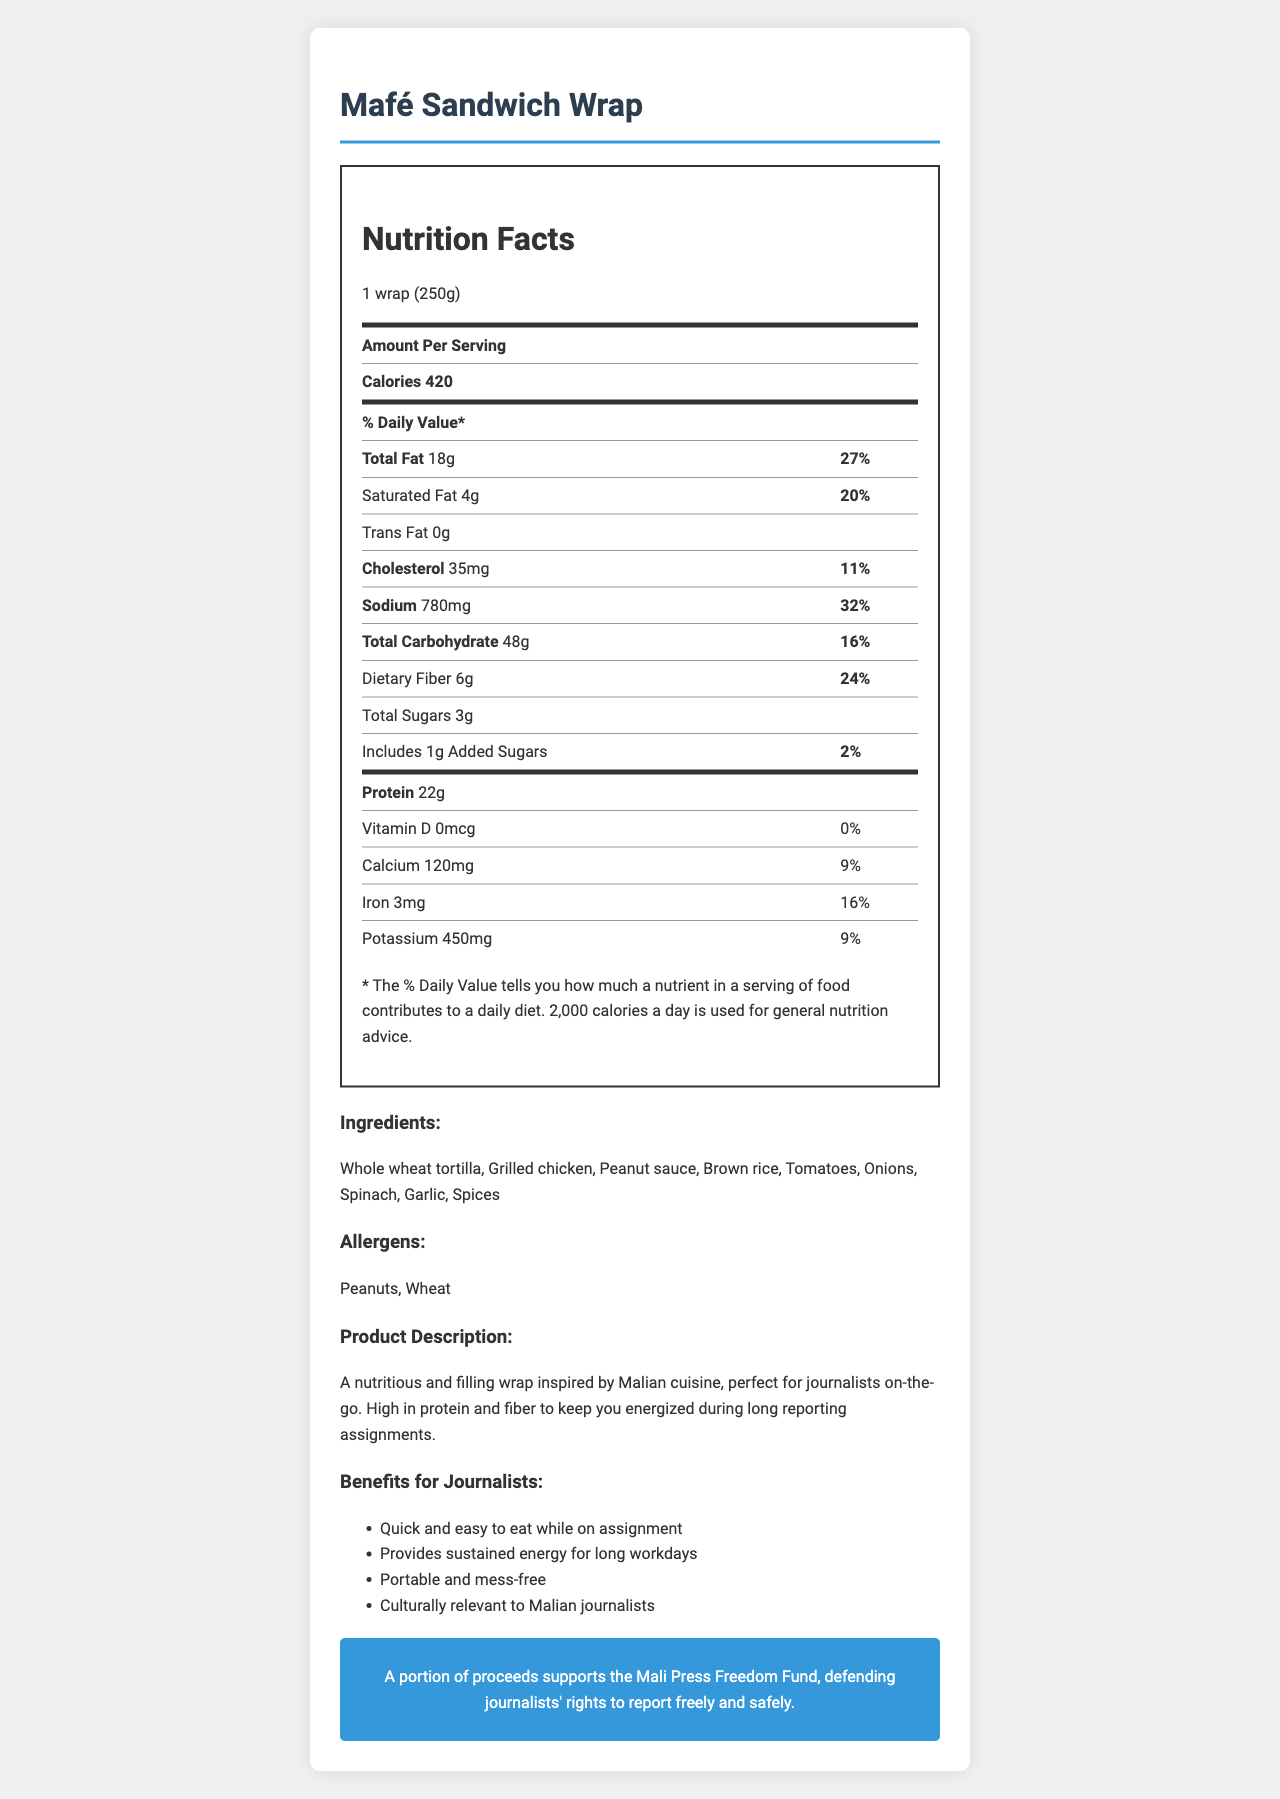what is the name of the product? The product name is clearly listed at the beginning of the document, under the title "Nutrition Facts: Mafé Sandwich Wrap."
Answer: Mafé Sandwich Wrap what is the serving size? The serving size is listed below the title and product name, stating "1 wrap (250g)."
Answer: 1 wrap (250g) how much protein does one serving contain? The nutrition label under "Nutrition Facts" shows that one serving contains 22 grams of protein.
Answer: 22g what are the main ingredients in the Mafé Sandwich Wrap? These ingredients are listed under the "Ingredients" section of the document.
Answer: Whole wheat tortilla, Grilled chicken, Peanut sauce, Brown rice, Tomatoes, Onions, Spinach, Garlic, Spices how many grams of dietary fiber does the wrap have? The dietary fiber content is listed on the nutrition label under the "Total Carbohydrate" section.
Answer: 6g how is the product beneficial for journalists? The "Benefits for Journalists" section of the document lists these benefits.
Answer: Quick and easy to eat while on assignment, Provides sustained energy for long workdays, Portable and mess-free, Culturally relevant to Malian journalists how many calories does the Mafé Sandwich Wrap provide per serving? The nutrition label lists the calorie content as 420 per serving.
Answer: 420 which of the following allergens are present in the wrap? A. Dairy B. Soy C. Peanuts D. Shellfish The "Allergens" section lists "Peanuts" and "Wheat" as allergens present in the product.
Answer: C. Peanuts how much sodium is in one serving of the wrap? The sodium content is listed on the nutrition label as 780 milligrams per serving.
Answer: 780mg which nutrient has the highest daily value percentage in the wrap? A. Total Fat B. Cholesterol C. Sodium D. Dietary Fiber Sodium has the highest daily value percentage at 32%, as calculated from 780mg/2400mg.
Answer: C. Sodium how many grams of added sugars are in the wrap? The nutrition label lists the added sugars content as 1 gram per serving.
Answer: 1g is the Mafé Sandwich Wrap suitable for someone avoiding wheat? The "Allergens" section lists "Wheat" as one of the allergens, making it unsuitable for someone avoiding wheat.
Answer: No what ingredient gives the Mafé Sandwich Wrap a unique Malian flavor? The "Peanut sauce" listed in the ingredients is unique to Malian cuisine.
Answer: Peanut sauce what is the main purpose of the proceeds supporting the Mali Press Freedom Fund? The "press-freedom" section states that a portion of proceeds supports this cause.
Answer: Defending journalists' rights to report freely and safely summarize the main idea of the document. The document highlights the Mafé Sandwich Wrap's nutritional benefits, its ease of consumption for journalists, and its role in supporting press freedom in Mali.
Answer: This document is a detailed description of the Mafé Sandwich Wrap, a packaged meal designed for journalists on-the-go. It provides nutritional information, ingredients, allergens, benefits specific to journalists, storage instructions, and a note on its contribution to press freedom. what is the specific percentage of daily value for protein in the wrap? The document does not provide the percentage of daily value for protein, as it is not listed on the nutrition label.
Answer: Cannot be determined 